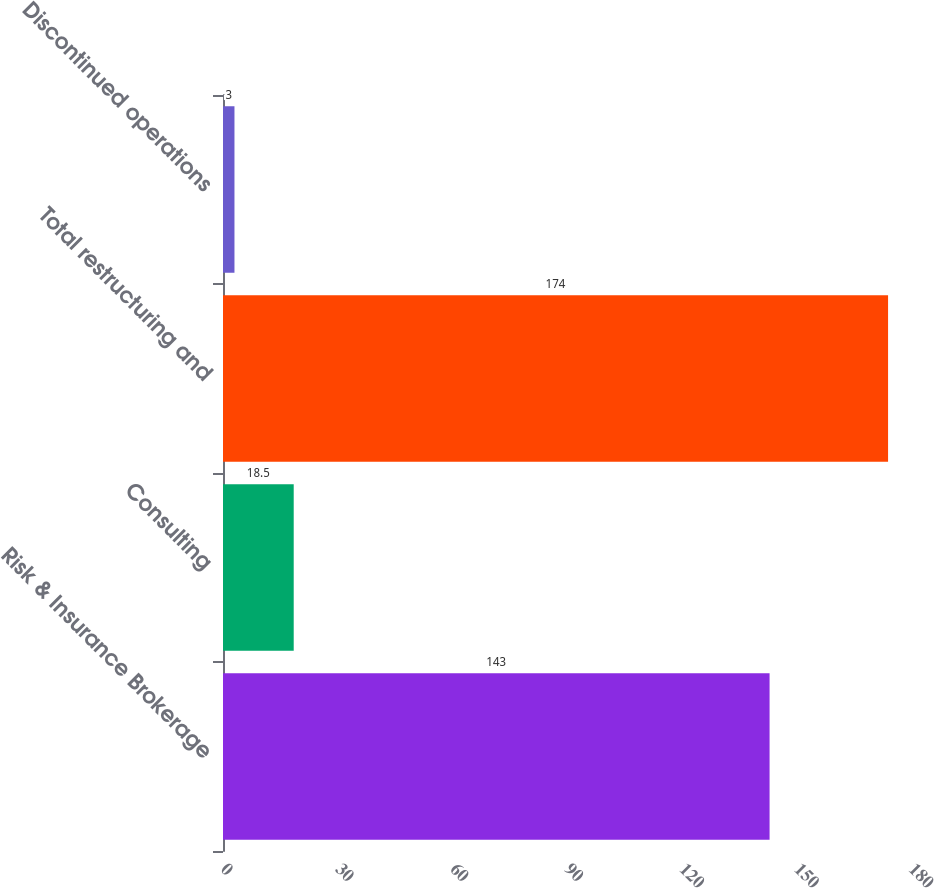<chart> <loc_0><loc_0><loc_500><loc_500><bar_chart><fcel>Risk & Insurance Brokerage<fcel>Consulting<fcel>Total restructuring and<fcel>Discontinued operations<nl><fcel>143<fcel>18.5<fcel>174<fcel>3<nl></chart> 